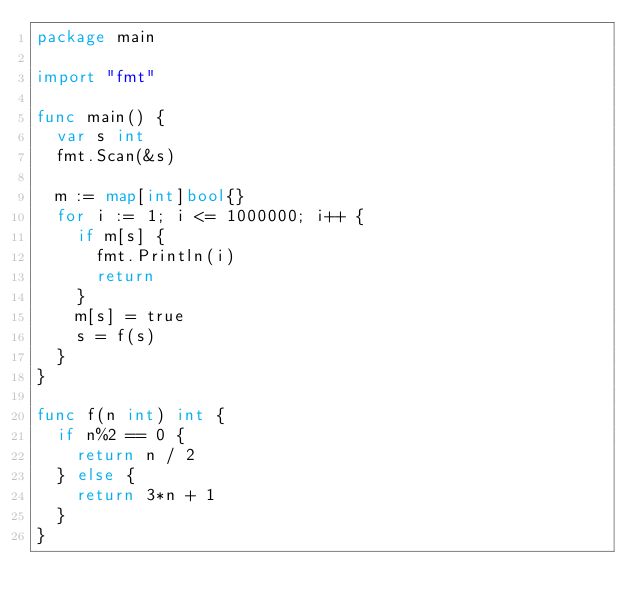<code> <loc_0><loc_0><loc_500><loc_500><_Go_>package main

import "fmt"

func main() {
	var s int
	fmt.Scan(&s)

	m := map[int]bool{}
	for i := 1; i <= 1000000; i++ {
		if m[s] {
			fmt.Println(i)
			return
		}
		m[s] = true
		s = f(s)
	}
}

func f(n int) int {
	if n%2 == 0 {
		return n / 2
	} else {
		return 3*n + 1
	}
}
</code> 